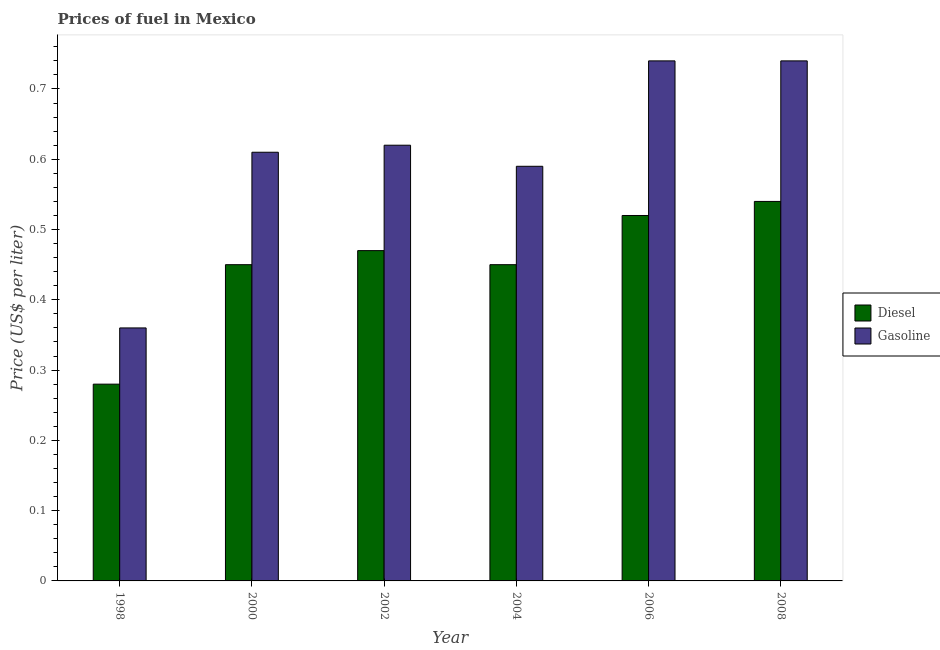How many different coloured bars are there?
Make the answer very short. 2. How many groups of bars are there?
Keep it short and to the point. 6. In how many cases, is the number of bars for a given year not equal to the number of legend labels?
Ensure brevity in your answer.  0. What is the diesel price in 2006?
Provide a short and direct response. 0.52. Across all years, what is the maximum diesel price?
Your response must be concise. 0.54. Across all years, what is the minimum diesel price?
Your response must be concise. 0.28. In which year was the gasoline price maximum?
Provide a succinct answer. 2006. What is the total diesel price in the graph?
Your answer should be compact. 2.71. What is the difference between the gasoline price in 2000 and that in 2008?
Your response must be concise. -0.13. What is the difference between the diesel price in 2000 and the gasoline price in 2006?
Your answer should be very brief. -0.07. What is the average diesel price per year?
Your answer should be very brief. 0.45. In how many years, is the diesel price greater than 0.14 US$ per litre?
Offer a very short reply. 6. What is the ratio of the diesel price in 2000 to that in 2006?
Ensure brevity in your answer.  0.87. Is the diesel price in 2000 less than that in 2006?
Your answer should be very brief. Yes. Is the difference between the gasoline price in 2002 and 2004 greater than the difference between the diesel price in 2002 and 2004?
Give a very brief answer. No. What is the difference between the highest and the second highest gasoline price?
Offer a terse response. 0. What is the difference between the highest and the lowest gasoline price?
Provide a succinct answer. 0.38. In how many years, is the diesel price greater than the average diesel price taken over all years?
Your response must be concise. 3. Is the sum of the diesel price in 2002 and 2008 greater than the maximum gasoline price across all years?
Keep it short and to the point. Yes. What does the 1st bar from the left in 2004 represents?
Your answer should be very brief. Diesel. What does the 1st bar from the right in 2008 represents?
Your response must be concise. Gasoline. How many years are there in the graph?
Give a very brief answer. 6. What is the difference between two consecutive major ticks on the Y-axis?
Offer a terse response. 0.1. Does the graph contain grids?
Ensure brevity in your answer.  No. What is the title of the graph?
Provide a short and direct response. Prices of fuel in Mexico. Does "Non-solid fuel" appear as one of the legend labels in the graph?
Give a very brief answer. No. What is the label or title of the X-axis?
Your answer should be very brief. Year. What is the label or title of the Y-axis?
Offer a terse response. Price (US$ per liter). What is the Price (US$ per liter) of Diesel in 1998?
Provide a succinct answer. 0.28. What is the Price (US$ per liter) in Gasoline in 1998?
Provide a succinct answer. 0.36. What is the Price (US$ per liter) of Diesel in 2000?
Provide a succinct answer. 0.45. What is the Price (US$ per liter) in Gasoline in 2000?
Give a very brief answer. 0.61. What is the Price (US$ per liter) in Diesel in 2002?
Offer a terse response. 0.47. What is the Price (US$ per liter) in Gasoline in 2002?
Give a very brief answer. 0.62. What is the Price (US$ per liter) of Diesel in 2004?
Provide a short and direct response. 0.45. What is the Price (US$ per liter) in Gasoline in 2004?
Ensure brevity in your answer.  0.59. What is the Price (US$ per liter) of Diesel in 2006?
Provide a succinct answer. 0.52. What is the Price (US$ per liter) in Gasoline in 2006?
Keep it short and to the point. 0.74. What is the Price (US$ per liter) in Diesel in 2008?
Make the answer very short. 0.54. What is the Price (US$ per liter) in Gasoline in 2008?
Keep it short and to the point. 0.74. Across all years, what is the maximum Price (US$ per liter) in Diesel?
Your answer should be compact. 0.54. Across all years, what is the maximum Price (US$ per liter) in Gasoline?
Your response must be concise. 0.74. Across all years, what is the minimum Price (US$ per liter) of Diesel?
Offer a very short reply. 0.28. Across all years, what is the minimum Price (US$ per liter) of Gasoline?
Provide a short and direct response. 0.36. What is the total Price (US$ per liter) in Diesel in the graph?
Ensure brevity in your answer.  2.71. What is the total Price (US$ per liter) in Gasoline in the graph?
Give a very brief answer. 3.66. What is the difference between the Price (US$ per liter) in Diesel in 1998 and that in 2000?
Provide a succinct answer. -0.17. What is the difference between the Price (US$ per liter) of Gasoline in 1998 and that in 2000?
Your response must be concise. -0.25. What is the difference between the Price (US$ per liter) in Diesel in 1998 and that in 2002?
Ensure brevity in your answer.  -0.19. What is the difference between the Price (US$ per liter) of Gasoline in 1998 and that in 2002?
Offer a very short reply. -0.26. What is the difference between the Price (US$ per liter) in Diesel in 1998 and that in 2004?
Your answer should be compact. -0.17. What is the difference between the Price (US$ per liter) of Gasoline in 1998 and that in 2004?
Offer a very short reply. -0.23. What is the difference between the Price (US$ per liter) of Diesel in 1998 and that in 2006?
Give a very brief answer. -0.24. What is the difference between the Price (US$ per liter) of Gasoline in 1998 and that in 2006?
Provide a short and direct response. -0.38. What is the difference between the Price (US$ per liter) in Diesel in 1998 and that in 2008?
Provide a short and direct response. -0.26. What is the difference between the Price (US$ per liter) in Gasoline in 1998 and that in 2008?
Your answer should be very brief. -0.38. What is the difference between the Price (US$ per liter) of Diesel in 2000 and that in 2002?
Give a very brief answer. -0.02. What is the difference between the Price (US$ per liter) of Gasoline in 2000 and that in 2002?
Offer a very short reply. -0.01. What is the difference between the Price (US$ per liter) in Gasoline in 2000 and that in 2004?
Ensure brevity in your answer.  0.02. What is the difference between the Price (US$ per liter) of Diesel in 2000 and that in 2006?
Keep it short and to the point. -0.07. What is the difference between the Price (US$ per liter) of Gasoline in 2000 and that in 2006?
Ensure brevity in your answer.  -0.13. What is the difference between the Price (US$ per liter) in Diesel in 2000 and that in 2008?
Offer a terse response. -0.09. What is the difference between the Price (US$ per liter) in Gasoline in 2000 and that in 2008?
Your answer should be compact. -0.13. What is the difference between the Price (US$ per liter) of Diesel in 2002 and that in 2004?
Keep it short and to the point. 0.02. What is the difference between the Price (US$ per liter) in Gasoline in 2002 and that in 2004?
Make the answer very short. 0.03. What is the difference between the Price (US$ per liter) in Gasoline in 2002 and that in 2006?
Provide a short and direct response. -0.12. What is the difference between the Price (US$ per liter) in Diesel in 2002 and that in 2008?
Offer a terse response. -0.07. What is the difference between the Price (US$ per liter) in Gasoline in 2002 and that in 2008?
Make the answer very short. -0.12. What is the difference between the Price (US$ per liter) of Diesel in 2004 and that in 2006?
Provide a short and direct response. -0.07. What is the difference between the Price (US$ per liter) of Gasoline in 2004 and that in 2006?
Give a very brief answer. -0.15. What is the difference between the Price (US$ per liter) of Diesel in 2004 and that in 2008?
Provide a succinct answer. -0.09. What is the difference between the Price (US$ per liter) of Diesel in 2006 and that in 2008?
Ensure brevity in your answer.  -0.02. What is the difference between the Price (US$ per liter) in Diesel in 1998 and the Price (US$ per liter) in Gasoline in 2000?
Your answer should be compact. -0.33. What is the difference between the Price (US$ per liter) of Diesel in 1998 and the Price (US$ per liter) of Gasoline in 2002?
Make the answer very short. -0.34. What is the difference between the Price (US$ per liter) in Diesel in 1998 and the Price (US$ per liter) in Gasoline in 2004?
Your answer should be compact. -0.31. What is the difference between the Price (US$ per liter) of Diesel in 1998 and the Price (US$ per liter) of Gasoline in 2006?
Ensure brevity in your answer.  -0.46. What is the difference between the Price (US$ per liter) in Diesel in 1998 and the Price (US$ per liter) in Gasoline in 2008?
Ensure brevity in your answer.  -0.46. What is the difference between the Price (US$ per liter) of Diesel in 2000 and the Price (US$ per liter) of Gasoline in 2002?
Your answer should be very brief. -0.17. What is the difference between the Price (US$ per liter) in Diesel in 2000 and the Price (US$ per liter) in Gasoline in 2004?
Make the answer very short. -0.14. What is the difference between the Price (US$ per liter) of Diesel in 2000 and the Price (US$ per liter) of Gasoline in 2006?
Offer a very short reply. -0.29. What is the difference between the Price (US$ per liter) of Diesel in 2000 and the Price (US$ per liter) of Gasoline in 2008?
Your response must be concise. -0.29. What is the difference between the Price (US$ per liter) in Diesel in 2002 and the Price (US$ per liter) in Gasoline in 2004?
Give a very brief answer. -0.12. What is the difference between the Price (US$ per liter) of Diesel in 2002 and the Price (US$ per liter) of Gasoline in 2006?
Offer a very short reply. -0.27. What is the difference between the Price (US$ per liter) in Diesel in 2002 and the Price (US$ per liter) in Gasoline in 2008?
Your response must be concise. -0.27. What is the difference between the Price (US$ per liter) of Diesel in 2004 and the Price (US$ per liter) of Gasoline in 2006?
Provide a succinct answer. -0.29. What is the difference between the Price (US$ per liter) in Diesel in 2004 and the Price (US$ per liter) in Gasoline in 2008?
Provide a short and direct response. -0.29. What is the difference between the Price (US$ per liter) in Diesel in 2006 and the Price (US$ per liter) in Gasoline in 2008?
Offer a very short reply. -0.22. What is the average Price (US$ per liter) in Diesel per year?
Ensure brevity in your answer.  0.45. What is the average Price (US$ per liter) in Gasoline per year?
Provide a succinct answer. 0.61. In the year 1998, what is the difference between the Price (US$ per liter) in Diesel and Price (US$ per liter) in Gasoline?
Your answer should be very brief. -0.08. In the year 2000, what is the difference between the Price (US$ per liter) of Diesel and Price (US$ per liter) of Gasoline?
Keep it short and to the point. -0.16. In the year 2004, what is the difference between the Price (US$ per liter) of Diesel and Price (US$ per liter) of Gasoline?
Offer a terse response. -0.14. In the year 2006, what is the difference between the Price (US$ per liter) in Diesel and Price (US$ per liter) in Gasoline?
Your answer should be very brief. -0.22. What is the ratio of the Price (US$ per liter) of Diesel in 1998 to that in 2000?
Offer a very short reply. 0.62. What is the ratio of the Price (US$ per liter) of Gasoline in 1998 to that in 2000?
Make the answer very short. 0.59. What is the ratio of the Price (US$ per liter) in Diesel in 1998 to that in 2002?
Offer a terse response. 0.6. What is the ratio of the Price (US$ per liter) of Gasoline in 1998 to that in 2002?
Your response must be concise. 0.58. What is the ratio of the Price (US$ per liter) in Diesel in 1998 to that in 2004?
Provide a short and direct response. 0.62. What is the ratio of the Price (US$ per liter) in Gasoline in 1998 to that in 2004?
Make the answer very short. 0.61. What is the ratio of the Price (US$ per liter) of Diesel in 1998 to that in 2006?
Offer a terse response. 0.54. What is the ratio of the Price (US$ per liter) of Gasoline in 1998 to that in 2006?
Your response must be concise. 0.49. What is the ratio of the Price (US$ per liter) in Diesel in 1998 to that in 2008?
Offer a very short reply. 0.52. What is the ratio of the Price (US$ per liter) in Gasoline in 1998 to that in 2008?
Your response must be concise. 0.49. What is the ratio of the Price (US$ per liter) in Diesel in 2000 to that in 2002?
Ensure brevity in your answer.  0.96. What is the ratio of the Price (US$ per liter) in Gasoline in 2000 to that in 2002?
Your answer should be compact. 0.98. What is the ratio of the Price (US$ per liter) in Diesel in 2000 to that in 2004?
Make the answer very short. 1. What is the ratio of the Price (US$ per liter) of Gasoline in 2000 to that in 2004?
Your answer should be compact. 1.03. What is the ratio of the Price (US$ per liter) of Diesel in 2000 to that in 2006?
Offer a terse response. 0.87. What is the ratio of the Price (US$ per liter) in Gasoline in 2000 to that in 2006?
Provide a succinct answer. 0.82. What is the ratio of the Price (US$ per liter) of Gasoline in 2000 to that in 2008?
Give a very brief answer. 0.82. What is the ratio of the Price (US$ per liter) in Diesel in 2002 to that in 2004?
Offer a very short reply. 1.04. What is the ratio of the Price (US$ per liter) in Gasoline in 2002 to that in 2004?
Ensure brevity in your answer.  1.05. What is the ratio of the Price (US$ per liter) in Diesel in 2002 to that in 2006?
Offer a very short reply. 0.9. What is the ratio of the Price (US$ per liter) in Gasoline in 2002 to that in 2006?
Offer a terse response. 0.84. What is the ratio of the Price (US$ per liter) of Diesel in 2002 to that in 2008?
Your response must be concise. 0.87. What is the ratio of the Price (US$ per liter) of Gasoline in 2002 to that in 2008?
Provide a short and direct response. 0.84. What is the ratio of the Price (US$ per liter) of Diesel in 2004 to that in 2006?
Give a very brief answer. 0.87. What is the ratio of the Price (US$ per liter) in Gasoline in 2004 to that in 2006?
Make the answer very short. 0.8. What is the ratio of the Price (US$ per liter) of Diesel in 2004 to that in 2008?
Your answer should be very brief. 0.83. What is the ratio of the Price (US$ per liter) of Gasoline in 2004 to that in 2008?
Your response must be concise. 0.8. What is the ratio of the Price (US$ per liter) in Gasoline in 2006 to that in 2008?
Offer a terse response. 1. What is the difference between the highest and the lowest Price (US$ per liter) of Diesel?
Offer a terse response. 0.26. What is the difference between the highest and the lowest Price (US$ per liter) in Gasoline?
Keep it short and to the point. 0.38. 